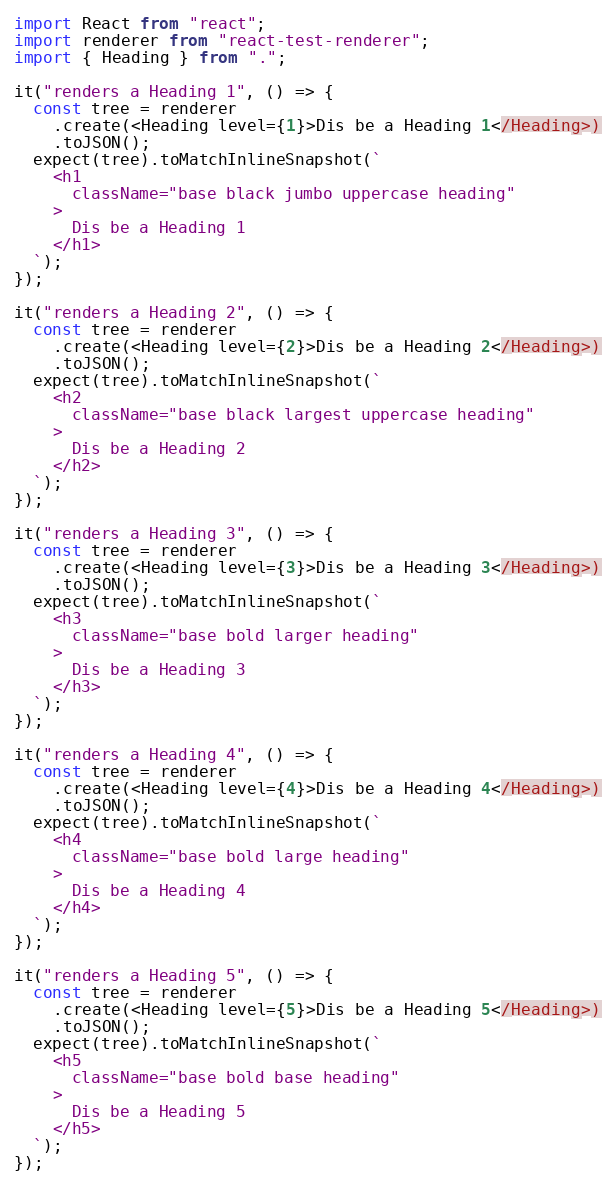<code> <loc_0><loc_0><loc_500><loc_500><_TypeScript_>import React from "react";
import renderer from "react-test-renderer";
import { Heading } from ".";

it("renders a Heading 1", () => {
  const tree = renderer
    .create(<Heading level={1}>Dis be a Heading 1</Heading>)
    .toJSON();
  expect(tree).toMatchInlineSnapshot(`
    <h1
      className="base black jumbo uppercase heading"
    >
      Dis be a Heading 1
    </h1>
  `);
});

it("renders a Heading 2", () => {
  const tree = renderer
    .create(<Heading level={2}>Dis be a Heading 2</Heading>)
    .toJSON();
  expect(tree).toMatchInlineSnapshot(`
    <h2
      className="base black largest uppercase heading"
    >
      Dis be a Heading 2
    </h2>
  `);
});

it("renders a Heading 3", () => {
  const tree = renderer
    .create(<Heading level={3}>Dis be a Heading 3</Heading>)
    .toJSON();
  expect(tree).toMatchInlineSnapshot(`
    <h3
      className="base bold larger heading"
    >
      Dis be a Heading 3
    </h3>
  `);
});

it("renders a Heading 4", () => {
  const tree = renderer
    .create(<Heading level={4}>Dis be a Heading 4</Heading>)
    .toJSON();
  expect(tree).toMatchInlineSnapshot(`
    <h4
      className="base bold large heading"
    >
      Dis be a Heading 4
    </h4>
  `);
});

it("renders a Heading 5", () => {
  const tree = renderer
    .create(<Heading level={5}>Dis be a Heading 5</Heading>)
    .toJSON();
  expect(tree).toMatchInlineSnapshot(`
    <h5
      className="base bold base heading"
    >
      Dis be a Heading 5
    </h5>
  `);
});
</code> 